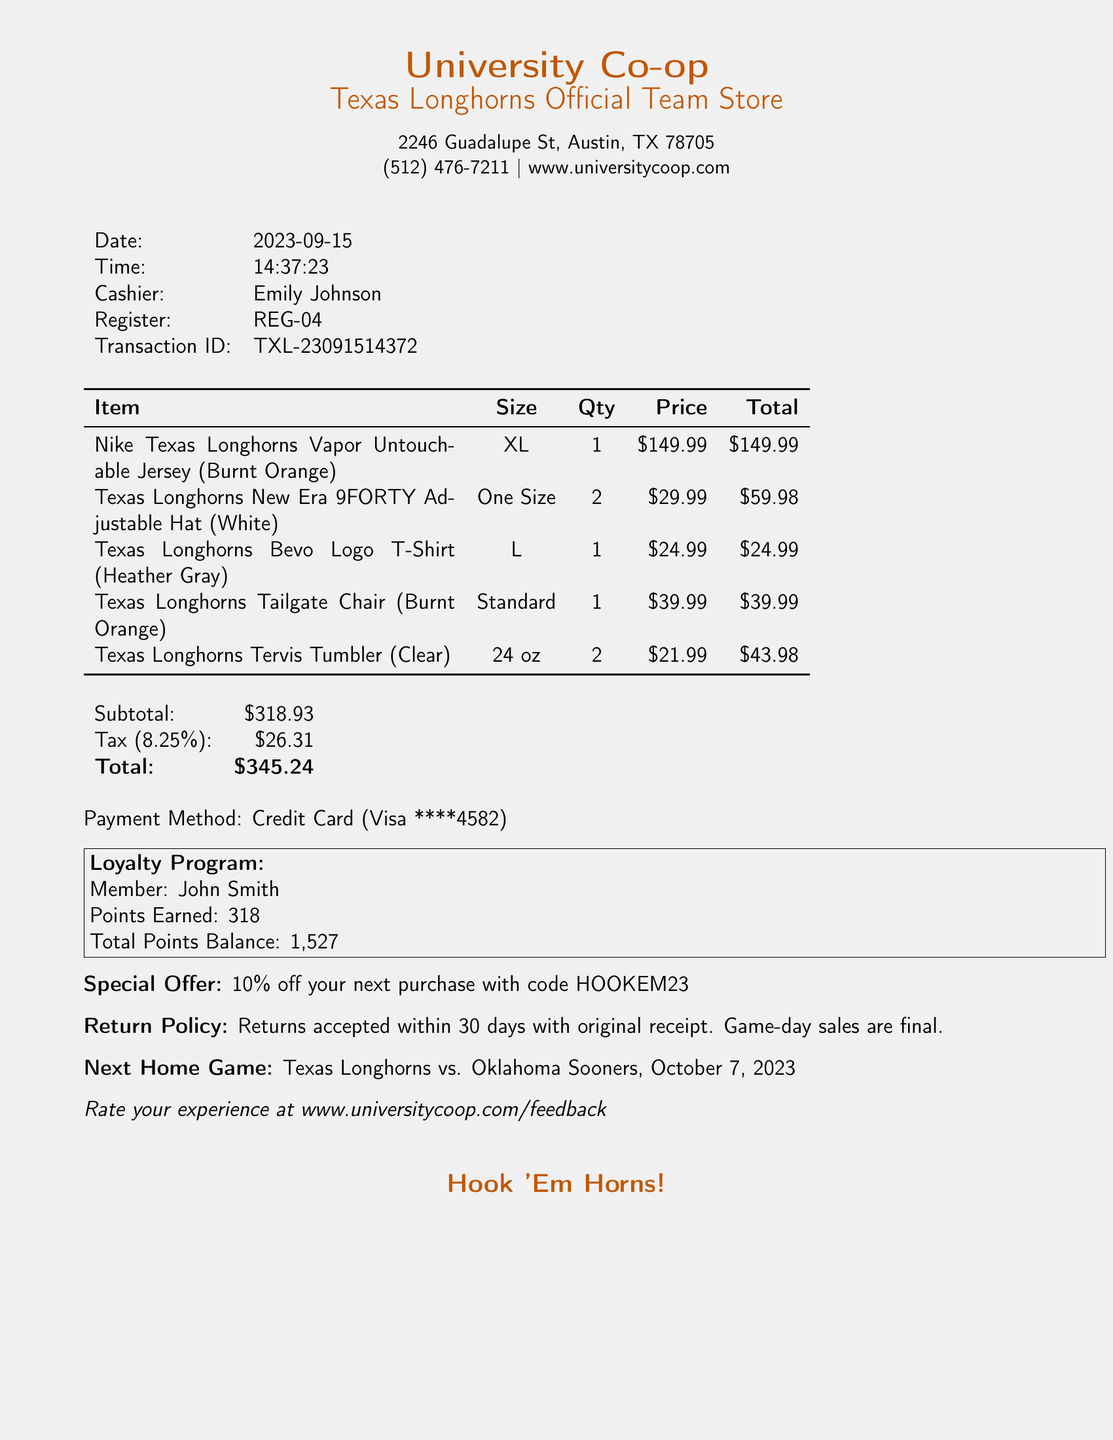What is the store name? The store name is prominently displayed at the top of the receipt.
Answer: University Co-op Texas Longhorns Official Team Store What is the date of the transaction? The date can be found near the top of the receipt under the date field.
Answer: 2023-09-15 Who was the cashier for this transaction? The cashier's name is indicated in a designated field on the receipt.
Answer: Emily Johnson How many Texas Longhorns Tervis Tumblers were purchased? The quantity for the Tervis Tumbler is listed in the itemized section of the receipt.
Answer: 2 What was the subtotal of the purchase? The subtotal is presented in the financial summary section of the receipt.
Answer: 318.93 What is the next home game for the Texas Longhorns? The information about the next home game is listed near the end of the receipt.
Answer: Texas Longhorns vs. Oklahoma Sooners, October 7, 2023 What is the total amount charged? The total amount appears in bold in the financial summary section of the receipt.
Answer: 345.24 What special offer is mentioned? The special offer is printed in the promotional section of the receipt.
Answer: 10% off your next purchase with code HOOKEM23 What is the return policy timeframe? The return policy timeframe is described specifically in the return policy section.
Answer: 30 days with original receipt 